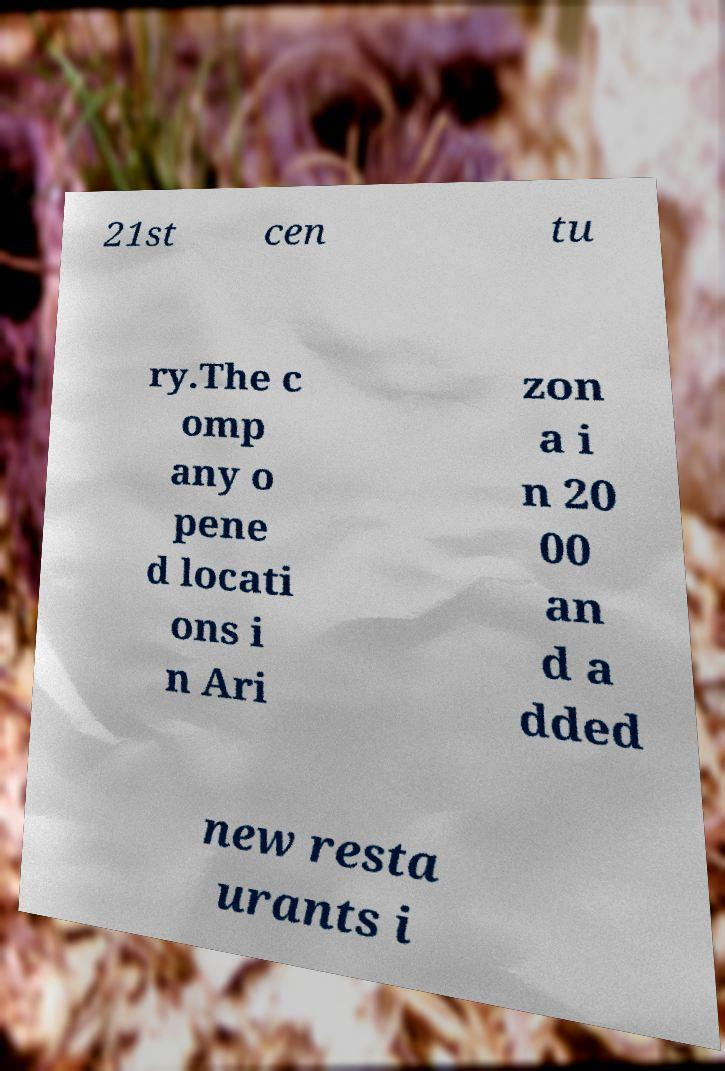Could you extract and type out the text from this image? 21st cen tu ry.The c omp any o pene d locati ons i n Ari zon a i n 20 00 an d a dded new resta urants i 